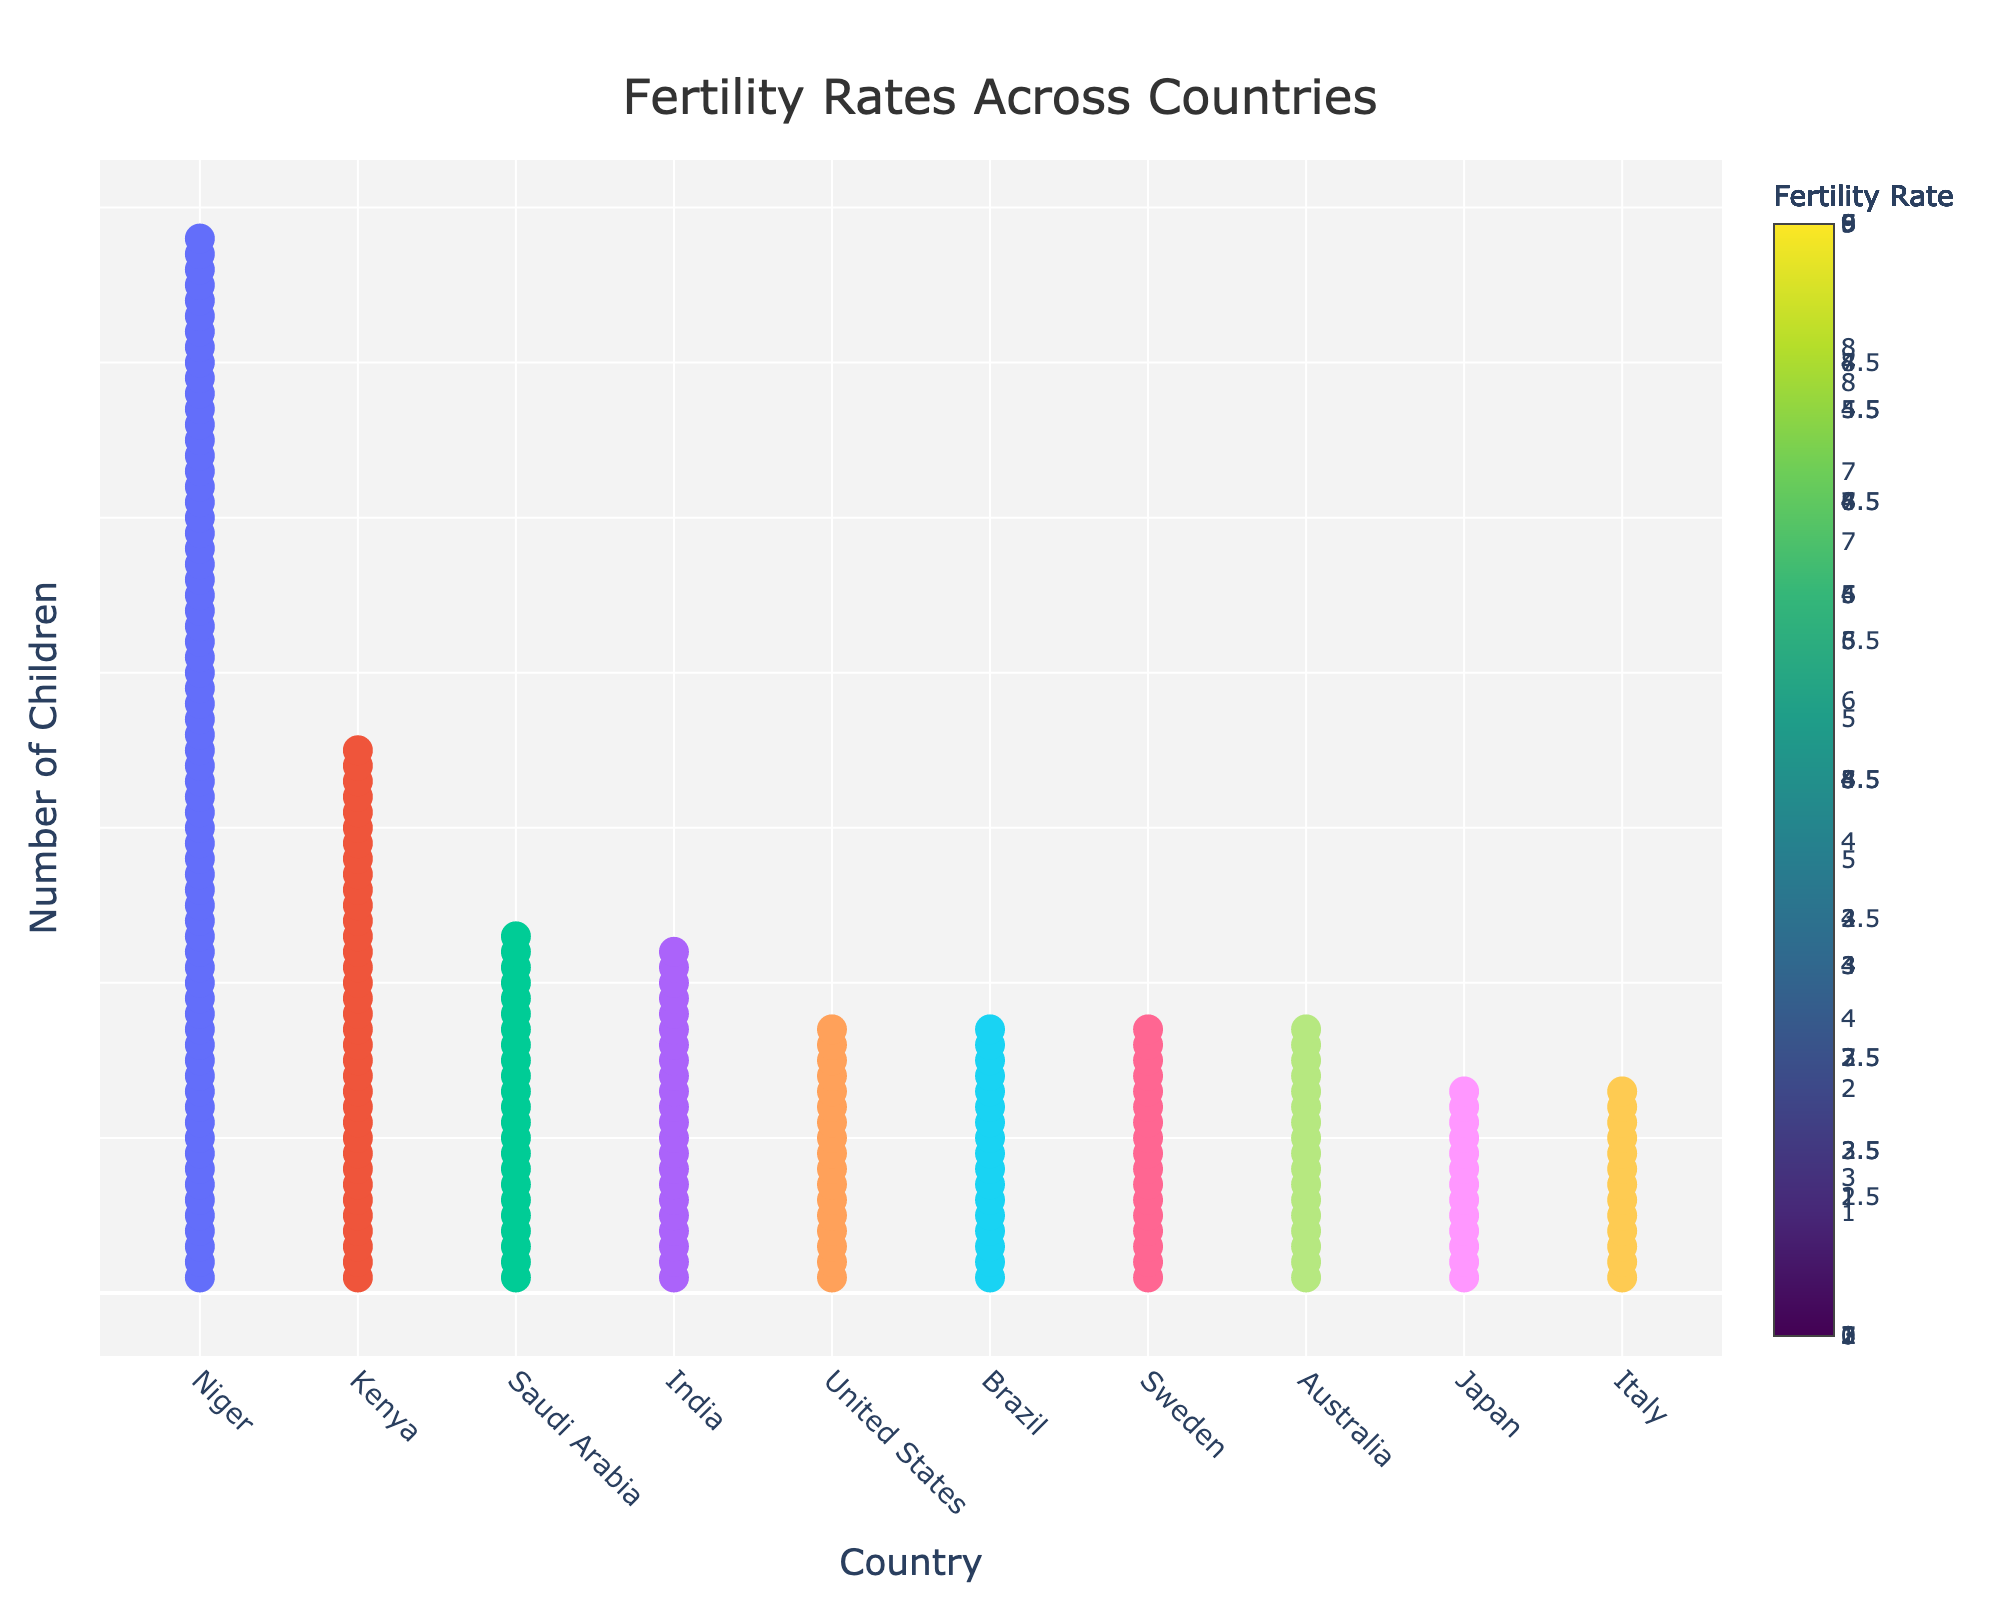What's the title of the figure? The title is placed at the top center of the figure, and it is easy to read. It tells us the main topic of the figure.
Answer: Fertility Rates Across Countries Which country has the highest fertility rate? Niger has the most number of icons (68), which corresponds to the highest fertility rate as depicted by the tallest column in the isotype plot.
Answer: Niger How many countries have a fertility rate of 1.7? Count the rows for the countries with columns containing 17 icons, which represent a fertility rate of 1.7.
Answer: 4 What is the fertility rate difference between India and Japan? Look at the y-axis values for India and Japan. India has 22 icons and Japan has 13, so the fertility rates are 2.2 and 1.3, respectively. Subtract the latter from the former.
Answer: 0.9 Which two countries have the same fertility rate of 1.3? Identify the rows with columns having 13 icons. These countries are Japan and Italy.
Answer: Japan and Italy What's the median fertility rate among these countries? List the fertility rates in ascending order (1.3, 1.3, 1.7, 1.7, 1.7, 1.7, 2.2, 2.3, 3.5, 6.8) and find the median, which is the middle value(s) in this sorted list.
Answer: 1.7 Compare the fertility rate of Kenya and Brazil. Which one is higher and by how much? Kenya has 35 icons (3.5) and Brazil has 17 icons (1.7). Subtract Brazil's rate from Kenya's rate.
Answer: Kenya, 1.8 What’s the total number of children represented in this plot? Sum the total number of icons representing each country. (68 + 13 + 17 + 22 + 13 + 35 + 17 + 17 + 23 + 17)
Answer: 242 How does the fertility rate of Saudi Arabia compare to that of Australia? Saudi Arabia has 2.3 (23 icons) and Australia has 1.7 (17 icons). Saudi Arabia's fertility rate is higher.
Answer: Saudi Arabia, 0.6 What can you infer about Sweden and the United States based on their fertility rates? Both countries have 17 icons which represent a fertility rate of 1.7. This indicates they have similar fertility rates.
Answer: Same, 1.7 